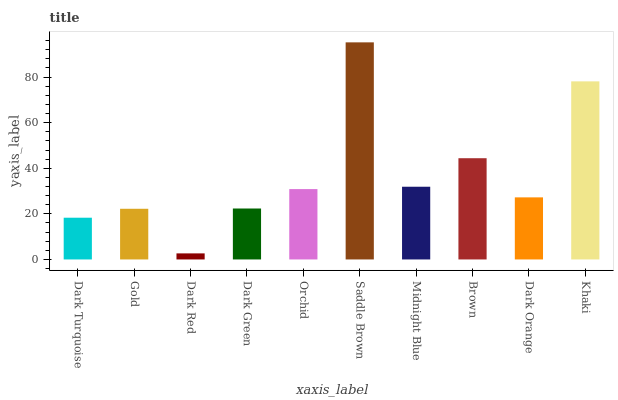Is Dark Red the minimum?
Answer yes or no. Yes. Is Saddle Brown the maximum?
Answer yes or no. Yes. Is Gold the minimum?
Answer yes or no. No. Is Gold the maximum?
Answer yes or no. No. Is Gold greater than Dark Turquoise?
Answer yes or no. Yes. Is Dark Turquoise less than Gold?
Answer yes or no. Yes. Is Dark Turquoise greater than Gold?
Answer yes or no. No. Is Gold less than Dark Turquoise?
Answer yes or no. No. Is Orchid the high median?
Answer yes or no. Yes. Is Dark Orange the low median?
Answer yes or no. Yes. Is Dark Green the high median?
Answer yes or no. No. Is Dark Red the low median?
Answer yes or no. No. 